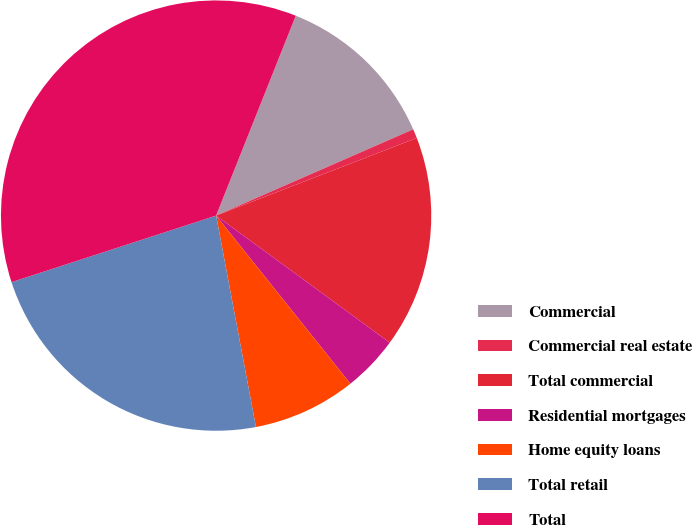<chart> <loc_0><loc_0><loc_500><loc_500><pie_chart><fcel>Commercial<fcel>Commercial real estate<fcel>Total commercial<fcel>Residential mortgages<fcel>Home equity loans<fcel>Total retail<fcel>Total<nl><fcel>12.4%<fcel>0.69%<fcel>15.93%<fcel>4.22%<fcel>7.76%<fcel>22.96%<fcel>36.04%<nl></chart> 